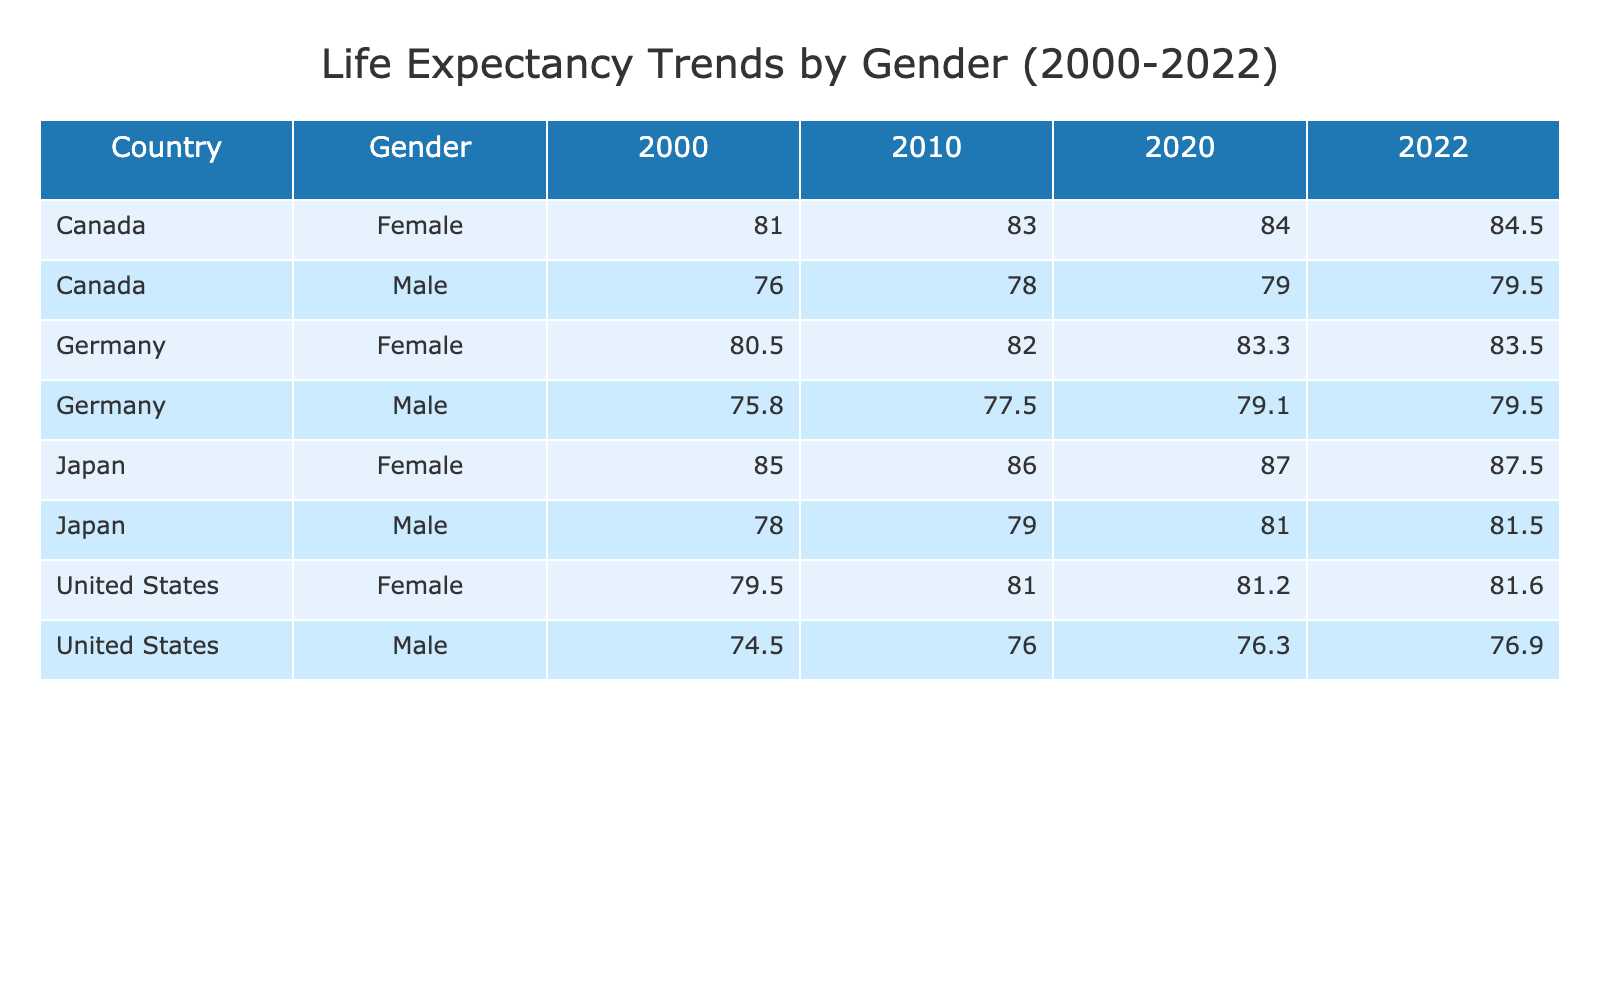What was the life expectancy of females in Japan in 2010? The table indicates that in the year 2010, for females in Japan, the life expectancy recorded was 86.0. This can be directly observed from the row where Japan is listed under the Female gender for the year 2010.
Answer: 86.0 What is the difference in life expectancy between males and females in Canada in 2022? Referring to the table for Canada in 2022, the life expectancy for males is 79.5 and for females is 84.5. To find the difference, we subtract the male life expectancy from the female life expectancy: 84.5 - 79.5 = 5.0.
Answer: 5.0 Did life expectancy for females in the United States increase from 2000 to 2022? In 2000, the life expectancy for females in the United States was 79.5, and by 2022 it rose to 81.6. Since 81.6 is greater than 79.5, we can confirm that there was indeed an increase.
Answer: Yes What was the average life expectancy of males across all countries in 2020? To calculate this, we first identify the life expectancies of males for 2020: 76.3 (United States), 79.0 (Canada), 79.1 (Germany), and 81.0 (Japan). Adding these values gives us 76.3 + 79.0 + 79.1 + 81.0 = 315.4. We then divide this total by the number of entries (4): 315.4 / 4 = 78.85.
Answer: 78.85 How much did the life expectancy of males in Germany change from 2000 to 2022? In 2000, the life expectancy for males in Germany was 75.8, and in 2022 it changed to 79.5. To assess the change, we subtract the earlier value from the later one: 79.5 - 75.8 = 3.7. Thus, there was an increase of 3.7 years over the period.
Answer: 3.7 What was the highest recorded life expectancy for females among the listed countries in 2022? Scanning the table for the row entries concerning the life expectancy of females in 2022, we find Japan with a life expectancy of 87.5, which is the highest value when compared to females from the other countries in that year.
Answer: 87.5 Did life expectancy in Germany for males exceed 78 in any of the years listed? Reviewing the table for Germany's male life expectancies: 75.8 in 2000, 77.5 in 2010, 79.1 in 2020, and 79.5 in 2022. Since all values before 2020 are below 78, and both 79.1 and 79.5 exceed this threshold, we conclude the answer is yes.
Answer: Yes Which gender in Japan had a higher life expectancy in 2020? In the year 2020, the table shows that the life expectancy for males in Japan was 81.0, while for females it was 87.0. Since 87.0 is greater than 81.0, females had a higher life expectancy in that year.
Answer: Females 